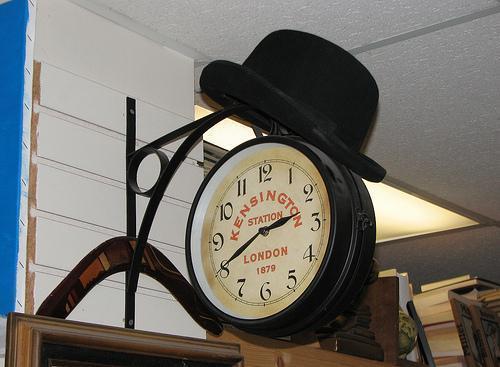How many clocks are visible in the picture?
Give a very brief answer. 1. How many clocks are there?
Give a very brief answer. 1. 